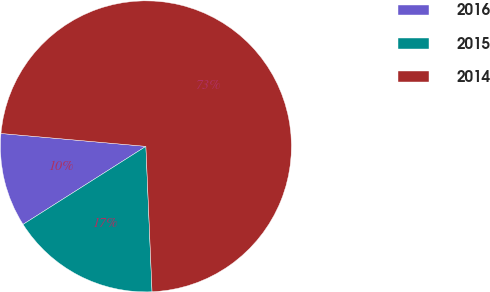Convert chart to OTSL. <chart><loc_0><loc_0><loc_500><loc_500><pie_chart><fcel>2016<fcel>2015<fcel>2014<nl><fcel>10.42%<fcel>16.67%<fcel>72.92%<nl></chart> 